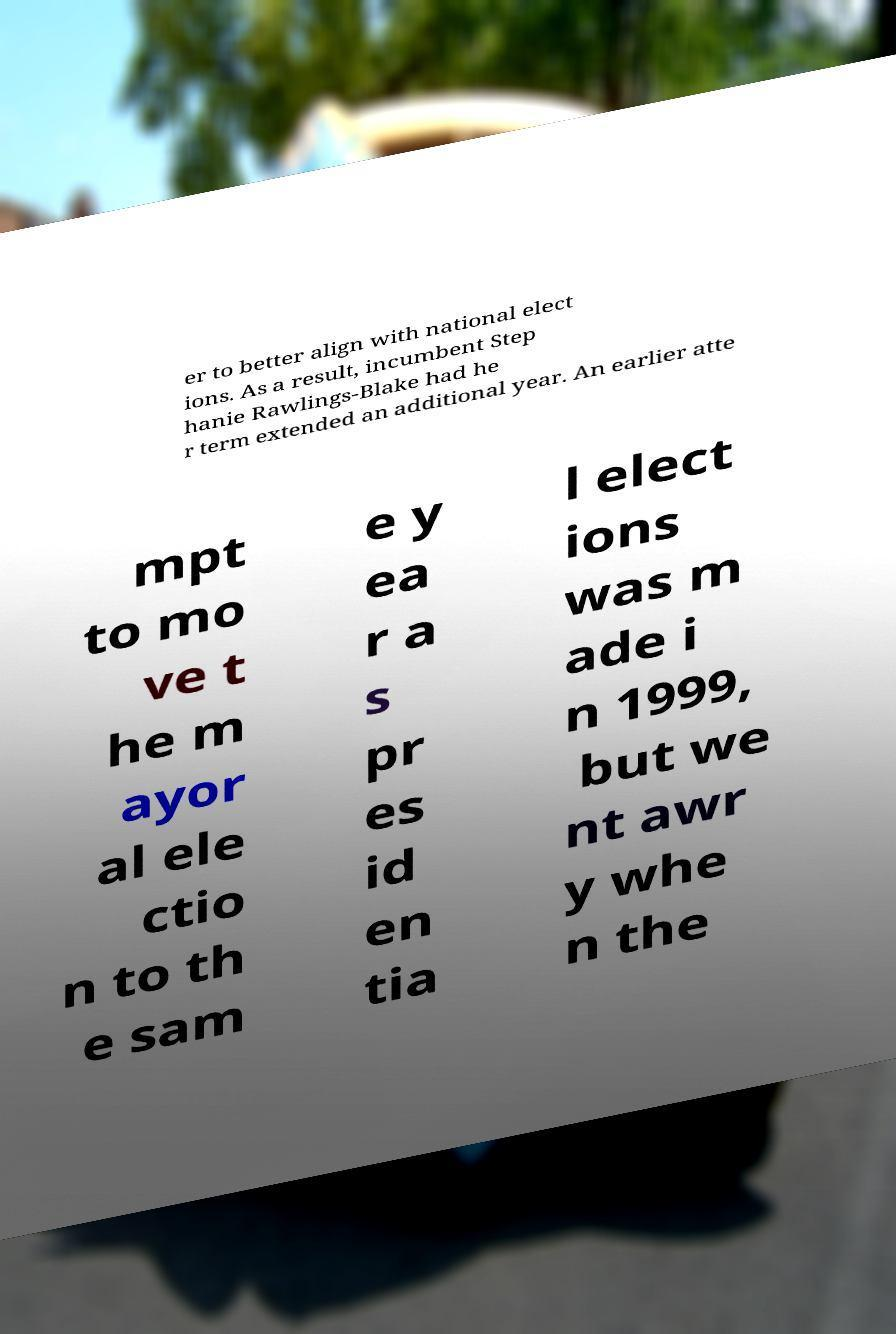What messages or text are displayed in this image? I need them in a readable, typed format. er to better align with national elect ions. As a result, incumbent Step hanie Rawlings-Blake had he r term extended an additional year. An earlier atte mpt to mo ve t he m ayor al ele ctio n to th e sam e y ea r a s pr es id en tia l elect ions was m ade i n 1999, but we nt awr y whe n the 